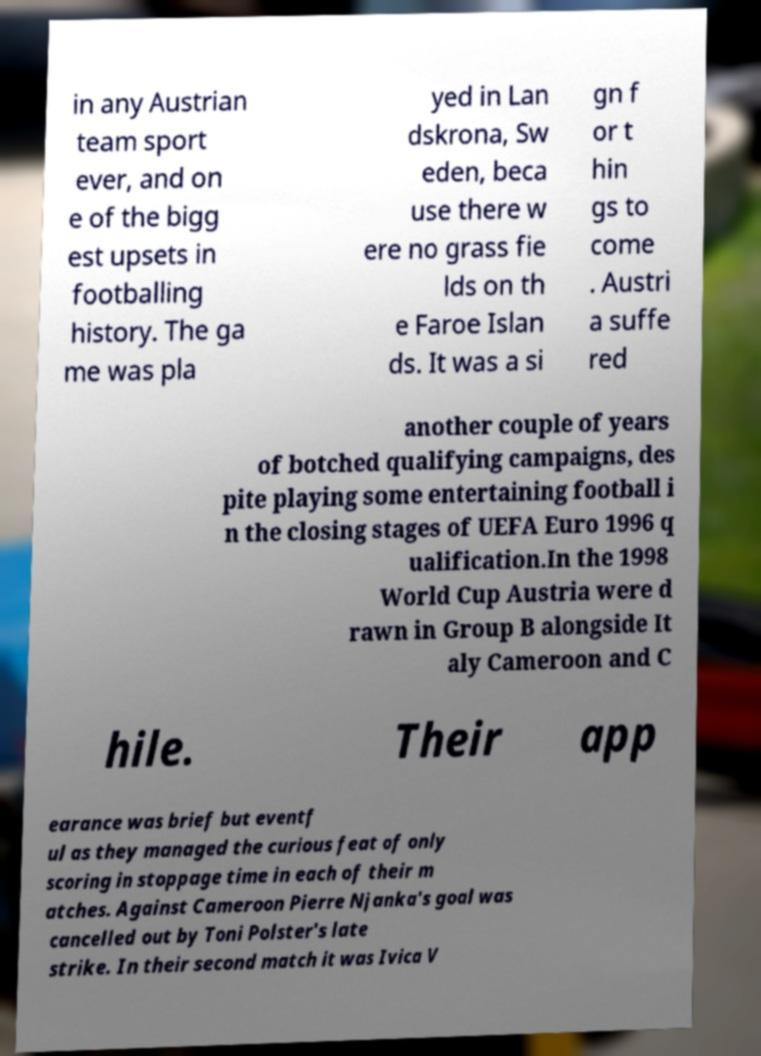Could you assist in decoding the text presented in this image and type it out clearly? in any Austrian team sport ever, and on e of the bigg est upsets in footballing history. The ga me was pla yed in Lan dskrona, Sw eden, beca use there w ere no grass fie lds on th e Faroe Islan ds. It was a si gn f or t hin gs to come . Austri a suffe red another couple of years of botched qualifying campaigns, des pite playing some entertaining football i n the closing stages of UEFA Euro 1996 q ualification.In the 1998 World Cup Austria were d rawn in Group B alongside It aly Cameroon and C hile. Their app earance was brief but eventf ul as they managed the curious feat of only scoring in stoppage time in each of their m atches. Against Cameroon Pierre Njanka's goal was cancelled out by Toni Polster's late strike. In their second match it was Ivica V 